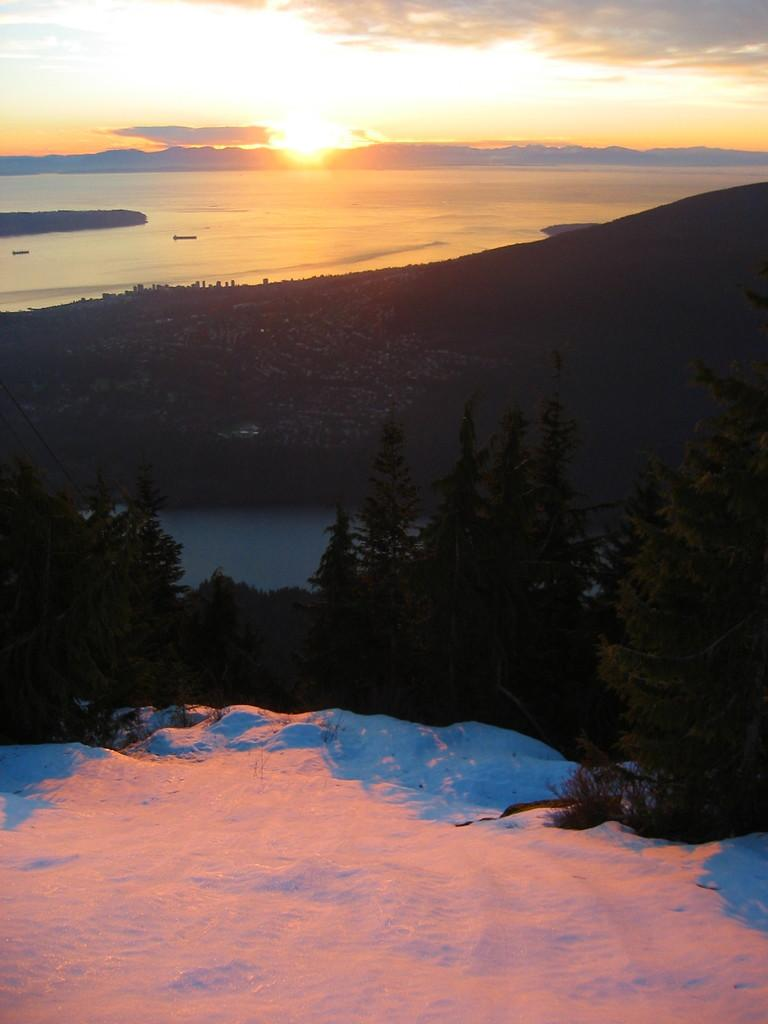What type of weather is depicted in the image? There is snow in the image, indicating cold weather. What natural elements can be seen in the image? There are trees, hills, and water visible in the image. What is visible in the background of the image? The sky is visible in the background of the image. Can you describe the celestial body visible in the sky? The sun is visible in the sky. What type of jail can be seen in the image? There is no jail present in the image; it features snow, trees, hills, water, sky, and the sun. 